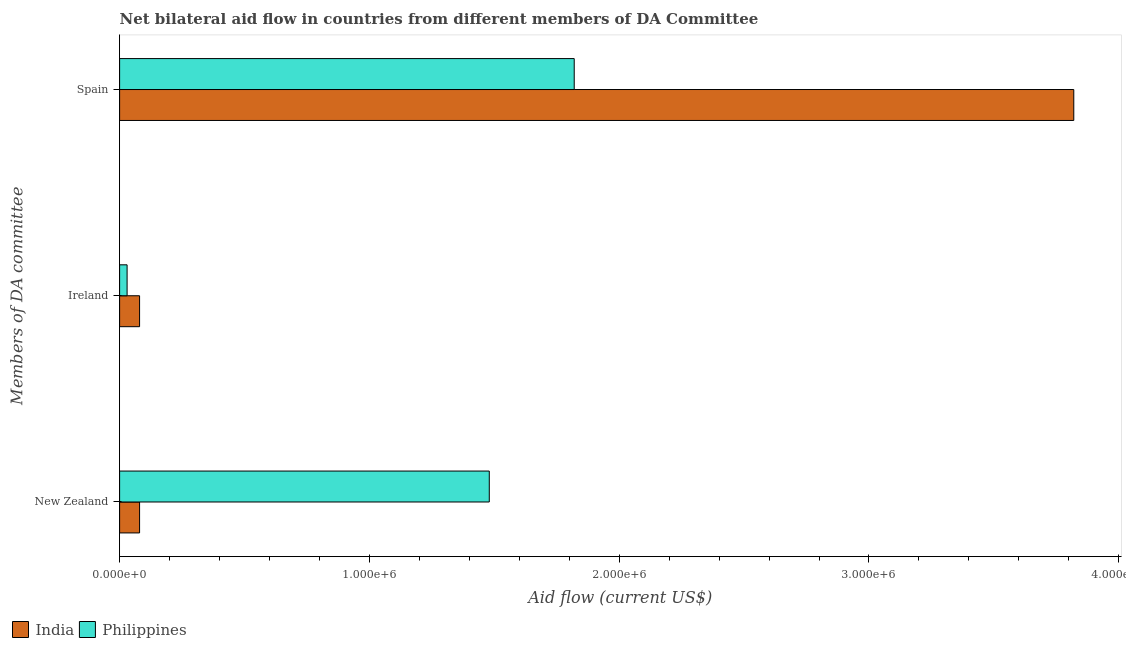How many different coloured bars are there?
Ensure brevity in your answer.  2. How many groups of bars are there?
Ensure brevity in your answer.  3. How many bars are there on the 2nd tick from the bottom?
Your answer should be very brief. 2. What is the label of the 3rd group of bars from the top?
Offer a very short reply. New Zealand. What is the amount of aid provided by new zealand in Philippines?
Provide a short and direct response. 1.48e+06. Across all countries, what is the maximum amount of aid provided by new zealand?
Keep it short and to the point. 1.48e+06. Across all countries, what is the minimum amount of aid provided by new zealand?
Ensure brevity in your answer.  8.00e+04. In which country was the amount of aid provided by ireland maximum?
Provide a short and direct response. India. What is the total amount of aid provided by spain in the graph?
Provide a succinct answer. 5.64e+06. What is the difference between the amount of aid provided by spain in Philippines and that in India?
Your response must be concise. -2.00e+06. What is the difference between the amount of aid provided by new zealand in Philippines and the amount of aid provided by ireland in India?
Keep it short and to the point. 1.40e+06. What is the average amount of aid provided by new zealand per country?
Your response must be concise. 7.80e+05. What is the difference between the amount of aid provided by spain and amount of aid provided by ireland in India?
Your answer should be compact. 3.74e+06. What is the ratio of the amount of aid provided by ireland in Philippines to that in India?
Your answer should be compact. 0.38. Is the amount of aid provided by spain in India less than that in Philippines?
Provide a short and direct response. No. What is the difference between the highest and the second highest amount of aid provided by spain?
Provide a short and direct response. 2.00e+06. What is the difference between the highest and the lowest amount of aid provided by spain?
Make the answer very short. 2.00e+06. In how many countries, is the amount of aid provided by spain greater than the average amount of aid provided by spain taken over all countries?
Keep it short and to the point. 1. Is the sum of the amount of aid provided by ireland in India and Philippines greater than the maximum amount of aid provided by spain across all countries?
Make the answer very short. No. What does the 1st bar from the bottom in Spain represents?
Provide a short and direct response. India. Is it the case that in every country, the sum of the amount of aid provided by new zealand and amount of aid provided by ireland is greater than the amount of aid provided by spain?
Give a very brief answer. No. How many bars are there?
Make the answer very short. 6. What is the difference between two consecutive major ticks on the X-axis?
Give a very brief answer. 1.00e+06. Does the graph contain any zero values?
Give a very brief answer. No. How many legend labels are there?
Ensure brevity in your answer.  2. What is the title of the graph?
Ensure brevity in your answer.  Net bilateral aid flow in countries from different members of DA Committee. Does "Syrian Arab Republic" appear as one of the legend labels in the graph?
Your answer should be compact. No. What is the label or title of the Y-axis?
Provide a succinct answer. Members of DA committee. What is the Aid flow (current US$) of India in New Zealand?
Provide a short and direct response. 8.00e+04. What is the Aid flow (current US$) in Philippines in New Zealand?
Give a very brief answer. 1.48e+06. What is the Aid flow (current US$) in India in Ireland?
Provide a short and direct response. 8.00e+04. What is the Aid flow (current US$) of India in Spain?
Your answer should be very brief. 3.82e+06. What is the Aid flow (current US$) in Philippines in Spain?
Make the answer very short. 1.82e+06. Across all Members of DA committee, what is the maximum Aid flow (current US$) in India?
Give a very brief answer. 3.82e+06. Across all Members of DA committee, what is the maximum Aid flow (current US$) in Philippines?
Offer a very short reply. 1.82e+06. Across all Members of DA committee, what is the minimum Aid flow (current US$) in India?
Your answer should be compact. 8.00e+04. What is the total Aid flow (current US$) of India in the graph?
Your answer should be compact. 3.98e+06. What is the total Aid flow (current US$) in Philippines in the graph?
Provide a short and direct response. 3.33e+06. What is the difference between the Aid flow (current US$) in Philippines in New Zealand and that in Ireland?
Your response must be concise. 1.45e+06. What is the difference between the Aid flow (current US$) of India in New Zealand and that in Spain?
Make the answer very short. -3.74e+06. What is the difference between the Aid flow (current US$) of Philippines in New Zealand and that in Spain?
Keep it short and to the point. -3.40e+05. What is the difference between the Aid flow (current US$) in India in Ireland and that in Spain?
Make the answer very short. -3.74e+06. What is the difference between the Aid flow (current US$) of Philippines in Ireland and that in Spain?
Your answer should be compact. -1.79e+06. What is the difference between the Aid flow (current US$) in India in New Zealand and the Aid flow (current US$) in Philippines in Spain?
Your response must be concise. -1.74e+06. What is the difference between the Aid flow (current US$) of India in Ireland and the Aid flow (current US$) of Philippines in Spain?
Provide a succinct answer. -1.74e+06. What is the average Aid flow (current US$) in India per Members of DA committee?
Your answer should be very brief. 1.33e+06. What is the average Aid flow (current US$) of Philippines per Members of DA committee?
Make the answer very short. 1.11e+06. What is the difference between the Aid flow (current US$) in India and Aid flow (current US$) in Philippines in New Zealand?
Ensure brevity in your answer.  -1.40e+06. What is the ratio of the Aid flow (current US$) of India in New Zealand to that in Ireland?
Ensure brevity in your answer.  1. What is the ratio of the Aid flow (current US$) in Philippines in New Zealand to that in Ireland?
Offer a terse response. 49.33. What is the ratio of the Aid flow (current US$) of India in New Zealand to that in Spain?
Provide a short and direct response. 0.02. What is the ratio of the Aid flow (current US$) of Philippines in New Zealand to that in Spain?
Offer a very short reply. 0.81. What is the ratio of the Aid flow (current US$) of India in Ireland to that in Spain?
Give a very brief answer. 0.02. What is the ratio of the Aid flow (current US$) of Philippines in Ireland to that in Spain?
Your answer should be compact. 0.02. What is the difference between the highest and the second highest Aid flow (current US$) of India?
Offer a very short reply. 3.74e+06. What is the difference between the highest and the lowest Aid flow (current US$) of India?
Offer a terse response. 3.74e+06. What is the difference between the highest and the lowest Aid flow (current US$) of Philippines?
Provide a succinct answer. 1.79e+06. 